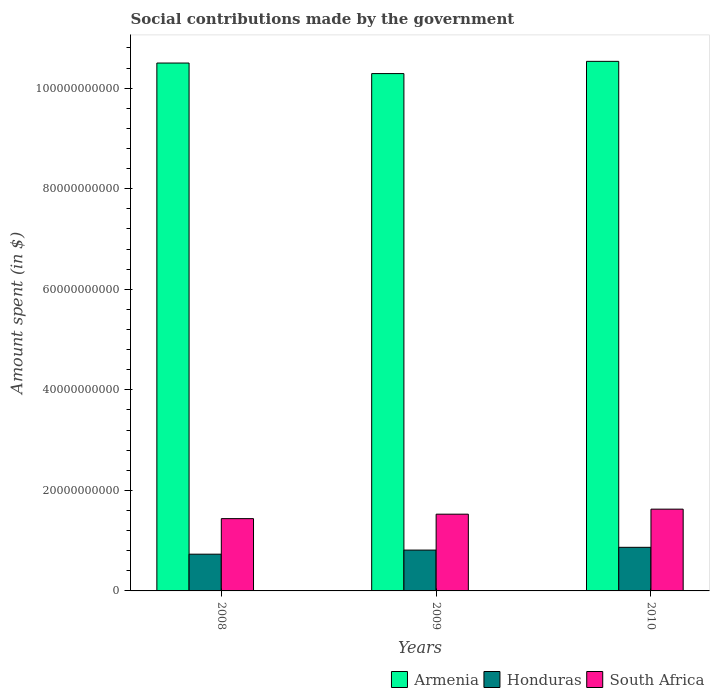Are the number of bars per tick equal to the number of legend labels?
Offer a terse response. Yes. Are the number of bars on each tick of the X-axis equal?
Your response must be concise. Yes. How many bars are there on the 2nd tick from the left?
Your response must be concise. 3. What is the amount spent on social contributions in Honduras in 2009?
Offer a terse response. 8.12e+09. Across all years, what is the maximum amount spent on social contributions in Armenia?
Provide a succinct answer. 1.05e+11. Across all years, what is the minimum amount spent on social contributions in Honduras?
Ensure brevity in your answer.  7.31e+09. What is the total amount spent on social contributions in Armenia in the graph?
Keep it short and to the point. 3.13e+11. What is the difference between the amount spent on social contributions in South Africa in 2008 and that in 2010?
Give a very brief answer. -1.89e+09. What is the difference between the amount spent on social contributions in Honduras in 2008 and the amount spent on social contributions in Armenia in 2010?
Offer a very short reply. -9.80e+1. What is the average amount spent on social contributions in South Africa per year?
Your answer should be compact. 1.53e+1. In the year 2008, what is the difference between the amount spent on social contributions in Armenia and amount spent on social contributions in South Africa?
Your answer should be very brief. 9.06e+1. What is the ratio of the amount spent on social contributions in Armenia in 2008 to that in 2009?
Make the answer very short. 1.02. Is the difference between the amount spent on social contributions in Armenia in 2008 and 2010 greater than the difference between the amount spent on social contributions in South Africa in 2008 and 2010?
Your response must be concise. Yes. What is the difference between the highest and the second highest amount spent on social contributions in South Africa?
Provide a succinct answer. 1.00e+09. What is the difference between the highest and the lowest amount spent on social contributions in Armenia?
Make the answer very short. 2.43e+09. In how many years, is the amount spent on social contributions in South Africa greater than the average amount spent on social contributions in South Africa taken over all years?
Give a very brief answer. 1. Is the sum of the amount spent on social contributions in Armenia in 2008 and 2010 greater than the maximum amount spent on social contributions in Honduras across all years?
Provide a succinct answer. Yes. What does the 3rd bar from the left in 2008 represents?
Your answer should be compact. South Africa. What does the 3rd bar from the right in 2010 represents?
Your response must be concise. Armenia. Is it the case that in every year, the sum of the amount spent on social contributions in South Africa and amount spent on social contributions in Honduras is greater than the amount spent on social contributions in Armenia?
Make the answer very short. No. Are all the bars in the graph horizontal?
Give a very brief answer. No. How many years are there in the graph?
Your answer should be compact. 3. Are the values on the major ticks of Y-axis written in scientific E-notation?
Keep it short and to the point. No. Does the graph contain any zero values?
Ensure brevity in your answer.  No. What is the title of the graph?
Give a very brief answer. Social contributions made by the government. Does "Solomon Islands" appear as one of the legend labels in the graph?
Your response must be concise. No. What is the label or title of the X-axis?
Offer a very short reply. Years. What is the label or title of the Y-axis?
Provide a succinct answer. Amount spent (in $). What is the Amount spent (in $) in Armenia in 2008?
Give a very brief answer. 1.05e+11. What is the Amount spent (in $) in Honduras in 2008?
Give a very brief answer. 7.31e+09. What is the Amount spent (in $) in South Africa in 2008?
Offer a very short reply. 1.44e+1. What is the Amount spent (in $) of Armenia in 2009?
Your answer should be compact. 1.03e+11. What is the Amount spent (in $) in Honduras in 2009?
Your response must be concise. 8.12e+09. What is the Amount spent (in $) of South Africa in 2009?
Your answer should be compact. 1.53e+1. What is the Amount spent (in $) of Armenia in 2010?
Offer a very short reply. 1.05e+11. What is the Amount spent (in $) of Honduras in 2010?
Provide a short and direct response. 8.67e+09. What is the Amount spent (in $) of South Africa in 2010?
Ensure brevity in your answer.  1.63e+1. Across all years, what is the maximum Amount spent (in $) of Armenia?
Provide a succinct answer. 1.05e+11. Across all years, what is the maximum Amount spent (in $) of Honduras?
Offer a terse response. 8.67e+09. Across all years, what is the maximum Amount spent (in $) of South Africa?
Give a very brief answer. 1.63e+1. Across all years, what is the minimum Amount spent (in $) in Armenia?
Give a very brief answer. 1.03e+11. Across all years, what is the minimum Amount spent (in $) of Honduras?
Offer a terse response. 7.31e+09. Across all years, what is the minimum Amount spent (in $) of South Africa?
Your response must be concise. 1.44e+1. What is the total Amount spent (in $) of Armenia in the graph?
Offer a very short reply. 3.13e+11. What is the total Amount spent (in $) in Honduras in the graph?
Make the answer very short. 2.41e+1. What is the total Amount spent (in $) in South Africa in the graph?
Provide a short and direct response. 4.59e+1. What is the difference between the Amount spent (in $) in Armenia in 2008 and that in 2009?
Your answer should be very brief. 2.10e+09. What is the difference between the Amount spent (in $) in Honduras in 2008 and that in 2009?
Ensure brevity in your answer.  -8.14e+08. What is the difference between the Amount spent (in $) in South Africa in 2008 and that in 2009?
Provide a short and direct response. -8.85e+08. What is the difference between the Amount spent (in $) of Armenia in 2008 and that in 2010?
Ensure brevity in your answer.  -3.35e+08. What is the difference between the Amount spent (in $) of Honduras in 2008 and that in 2010?
Make the answer very short. -1.36e+09. What is the difference between the Amount spent (in $) in South Africa in 2008 and that in 2010?
Make the answer very short. -1.89e+09. What is the difference between the Amount spent (in $) in Armenia in 2009 and that in 2010?
Provide a short and direct response. -2.43e+09. What is the difference between the Amount spent (in $) in Honduras in 2009 and that in 2010?
Ensure brevity in your answer.  -5.49e+08. What is the difference between the Amount spent (in $) in South Africa in 2009 and that in 2010?
Your answer should be very brief. -1.00e+09. What is the difference between the Amount spent (in $) in Armenia in 2008 and the Amount spent (in $) in Honduras in 2009?
Your answer should be compact. 9.69e+1. What is the difference between the Amount spent (in $) of Armenia in 2008 and the Amount spent (in $) of South Africa in 2009?
Ensure brevity in your answer.  8.97e+1. What is the difference between the Amount spent (in $) of Honduras in 2008 and the Amount spent (in $) of South Africa in 2009?
Offer a very short reply. -7.96e+09. What is the difference between the Amount spent (in $) in Armenia in 2008 and the Amount spent (in $) in Honduras in 2010?
Offer a very short reply. 9.63e+1. What is the difference between the Amount spent (in $) in Armenia in 2008 and the Amount spent (in $) in South Africa in 2010?
Offer a terse response. 8.87e+1. What is the difference between the Amount spent (in $) of Honduras in 2008 and the Amount spent (in $) of South Africa in 2010?
Make the answer very short. -8.96e+09. What is the difference between the Amount spent (in $) in Armenia in 2009 and the Amount spent (in $) in Honduras in 2010?
Keep it short and to the point. 9.42e+1. What is the difference between the Amount spent (in $) in Armenia in 2009 and the Amount spent (in $) in South Africa in 2010?
Make the answer very short. 8.66e+1. What is the difference between the Amount spent (in $) in Honduras in 2009 and the Amount spent (in $) in South Africa in 2010?
Provide a succinct answer. -8.14e+09. What is the average Amount spent (in $) of Armenia per year?
Offer a very short reply. 1.04e+11. What is the average Amount spent (in $) in Honduras per year?
Give a very brief answer. 8.03e+09. What is the average Amount spent (in $) in South Africa per year?
Your answer should be very brief. 1.53e+1. In the year 2008, what is the difference between the Amount spent (in $) of Armenia and Amount spent (in $) of Honduras?
Give a very brief answer. 9.77e+1. In the year 2008, what is the difference between the Amount spent (in $) of Armenia and Amount spent (in $) of South Africa?
Ensure brevity in your answer.  9.06e+1. In the year 2008, what is the difference between the Amount spent (in $) in Honduras and Amount spent (in $) in South Africa?
Your answer should be very brief. -7.07e+09. In the year 2009, what is the difference between the Amount spent (in $) in Armenia and Amount spent (in $) in Honduras?
Offer a very short reply. 9.48e+1. In the year 2009, what is the difference between the Amount spent (in $) of Armenia and Amount spent (in $) of South Africa?
Give a very brief answer. 8.76e+1. In the year 2009, what is the difference between the Amount spent (in $) in Honduras and Amount spent (in $) in South Africa?
Provide a short and direct response. -7.14e+09. In the year 2010, what is the difference between the Amount spent (in $) of Armenia and Amount spent (in $) of Honduras?
Your answer should be very brief. 9.67e+1. In the year 2010, what is the difference between the Amount spent (in $) of Armenia and Amount spent (in $) of South Africa?
Provide a succinct answer. 8.91e+1. In the year 2010, what is the difference between the Amount spent (in $) of Honduras and Amount spent (in $) of South Africa?
Provide a short and direct response. -7.59e+09. What is the ratio of the Amount spent (in $) of Armenia in 2008 to that in 2009?
Your response must be concise. 1.02. What is the ratio of the Amount spent (in $) in Honduras in 2008 to that in 2009?
Make the answer very short. 0.9. What is the ratio of the Amount spent (in $) in South Africa in 2008 to that in 2009?
Offer a very short reply. 0.94. What is the ratio of the Amount spent (in $) of Honduras in 2008 to that in 2010?
Give a very brief answer. 0.84. What is the ratio of the Amount spent (in $) of South Africa in 2008 to that in 2010?
Ensure brevity in your answer.  0.88. What is the ratio of the Amount spent (in $) in Armenia in 2009 to that in 2010?
Make the answer very short. 0.98. What is the ratio of the Amount spent (in $) of Honduras in 2009 to that in 2010?
Your answer should be compact. 0.94. What is the ratio of the Amount spent (in $) in South Africa in 2009 to that in 2010?
Offer a terse response. 0.94. What is the difference between the highest and the second highest Amount spent (in $) of Armenia?
Ensure brevity in your answer.  3.35e+08. What is the difference between the highest and the second highest Amount spent (in $) in Honduras?
Keep it short and to the point. 5.49e+08. What is the difference between the highest and the second highest Amount spent (in $) in South Africa?
Offer a very short reply. 1.00e+09. What is the difference between the highest and the lowest Amount spent (in $) in Armenia?
Provide a succinct answer. 2.43e+09. What is the difference between the highest and the lowest Amount spent (in $) of Honduras?
Offer a very short reply. 1.36e+09. What is the difference between the highest and the lowest Amount spent (in $) in South Africa?
Provide a short and direct response. 1.89e+09. 